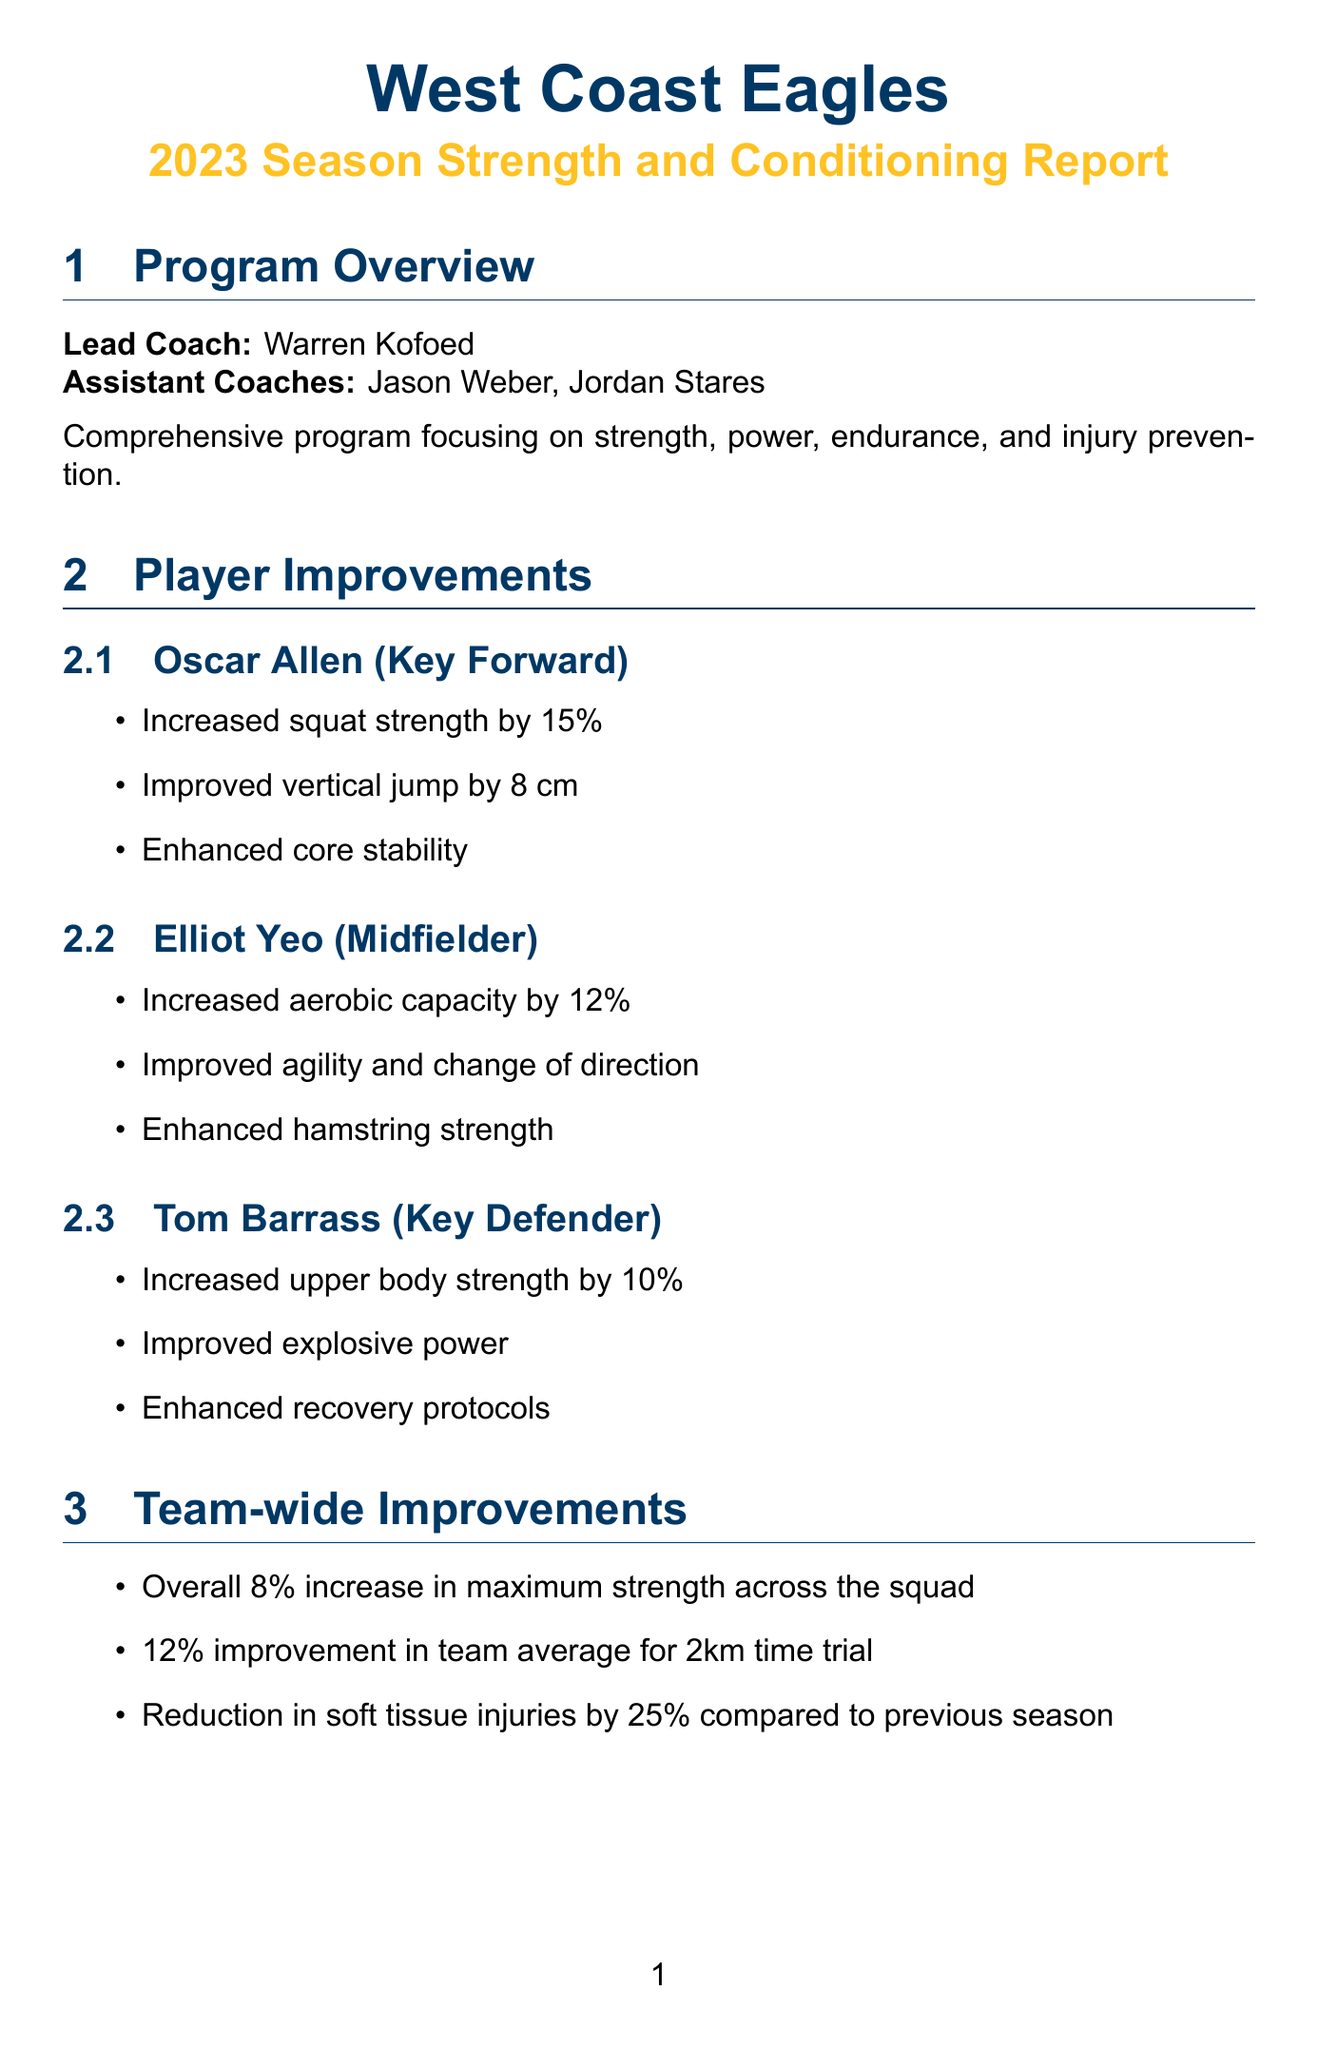what is the name of the lead coach? The lead coach is mentioned in the program overview section of the document.
Answer: Warren Kofoed how much did Oscar Allen's squat strength increase? This information is included in the player improvements section for Oscar Allen.
Answer: 15% what is the reduction in soft tissue injuries compared to the previous season? This statistic is provided in the team-wide improvements section.
Answer: 25% which players are targeted for speed development? The target players for speed development are listed in the areas for future focus section.
Answer: Liam Ryan, Jamie Cripps, Jack Petruccelle what type of recovery facilities are mentioned? The document specifies the recovery facilities available as part of the facilities and equipment section.
Answer: Hydrotherapy pool, Cryotherapy chamber, Altitude training room how is the endurance ranking described in the comparative analysis? Endurance ranking is listed along with the overall strength, speed, and injury prevention rankings in the comparative analysis section.
Answer: 6 what training method is suggested for maintaining explosive power output? This information is found in the areas for future focus section under power endurance.
Answer: Develop training methods who is the lead nutritionist? The document states the lead nutritionist's name in the nutrition program section.
Answer: Emily Apoloney which top performer is ranked in vertical jump? This information is provided in the comparative analysis section listing the top performers.
Answer: Nic Naitanui 